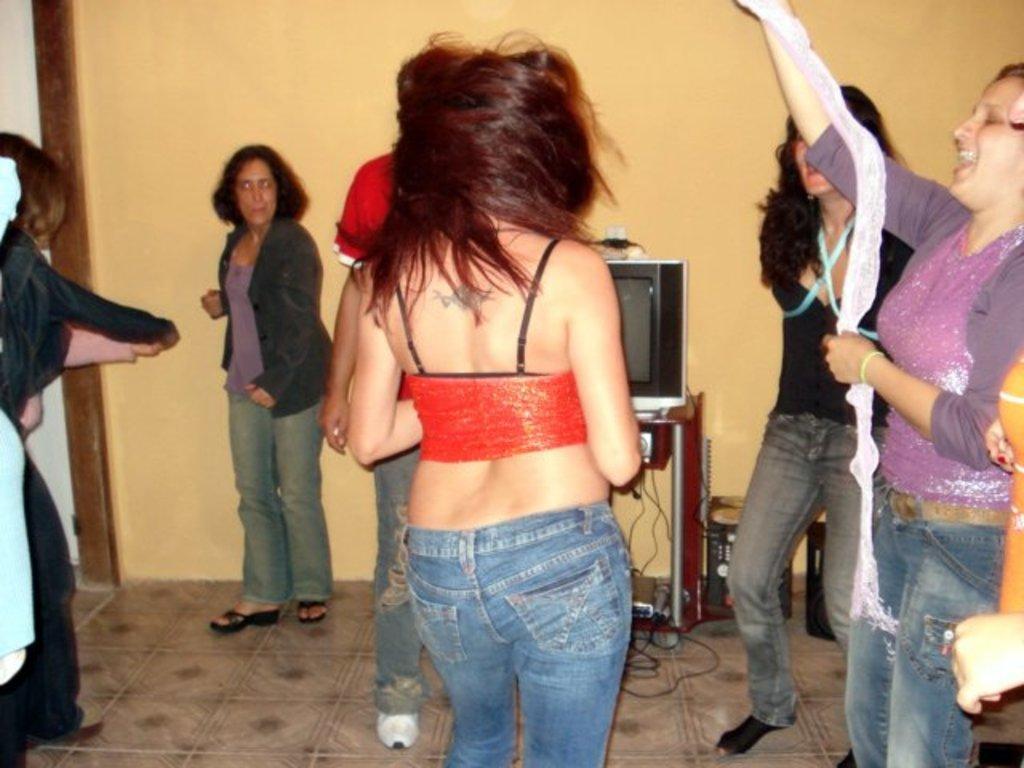Please provide a concise description of this image. This image consists of many people dancing in a room. At the bottom, there is a wall. In the front, there is a woman wearing blue jeans. In front of her there is a TV. 